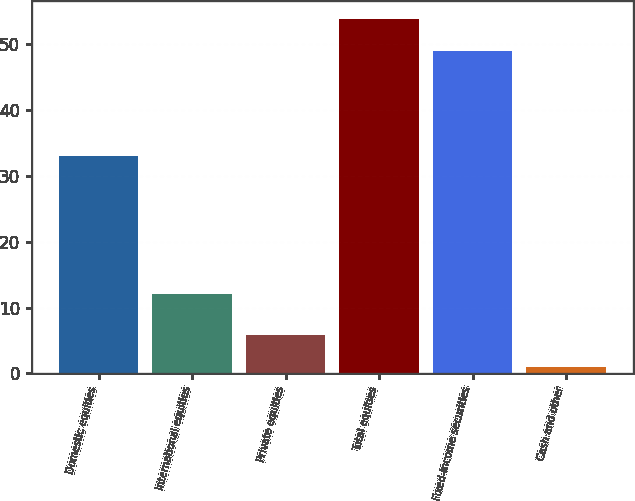<chart> <loc_0><loc_0><loc_500><loc_500><bar_chart><fcel>Domestic equities<fcel>International equities<fcel>Private equities<fcel>Total equities<fcel>Fixed-income securities<fcel>Cash and other<nl><fcel>33<fcel>12<fcel>5.9<fcel>53.9<fcel>49<fcel>1<nl></chart> 